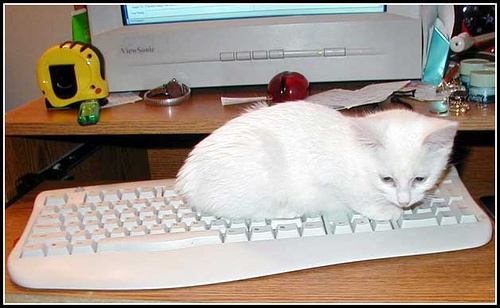Describe the objects in this image and their specific colors. I can see keyboard in black, lightgray, darkgray, and tan tones, cat in black, white, darkgray, and lightgray tones, tv in black, darkgray, and lightblue tones, and tv in black, lightblue, darkgray, and blue tones in this image. 